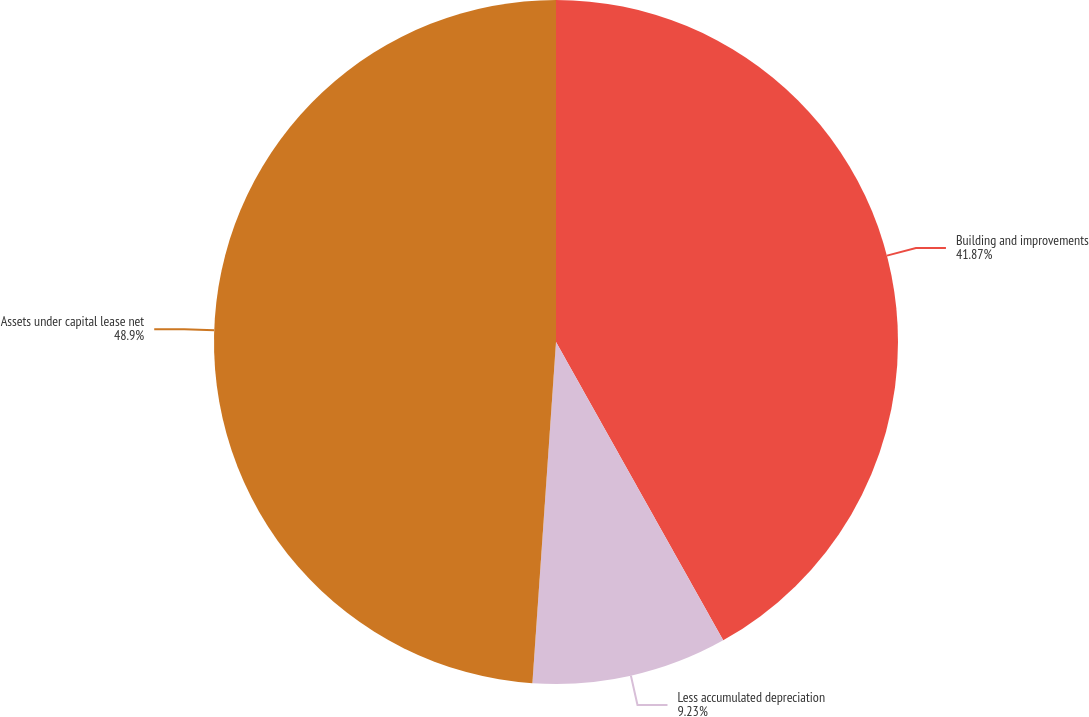<chart> <loc_0><loc_0><loc_500><loc_500><pie_chart><fcel>Building and improvements<fcel>Less accumulated depreciation<fcel>Assets under capital lease net<nl><fcel>41.87%<fcel>9.23%<fcel>48.9%<nl></chart> 